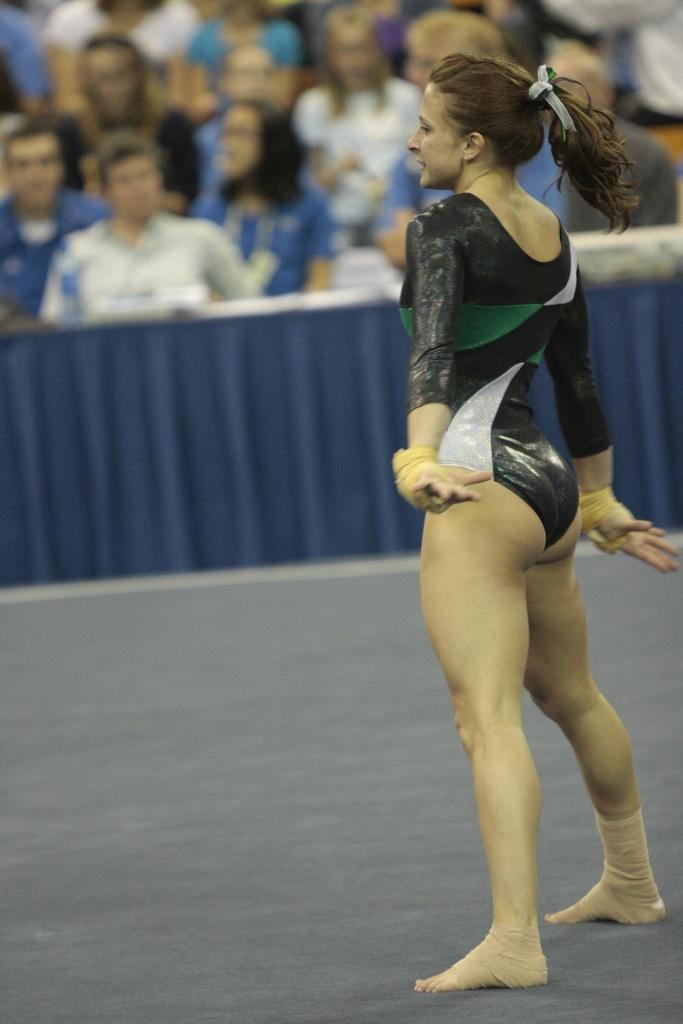Could you give a brief overview of what you see in this image? In this image I can see a woman is standing and I can see she is wearing black colour dress. In the background I can see few more people are sitting and I can see this image is little bit blurry from background. 